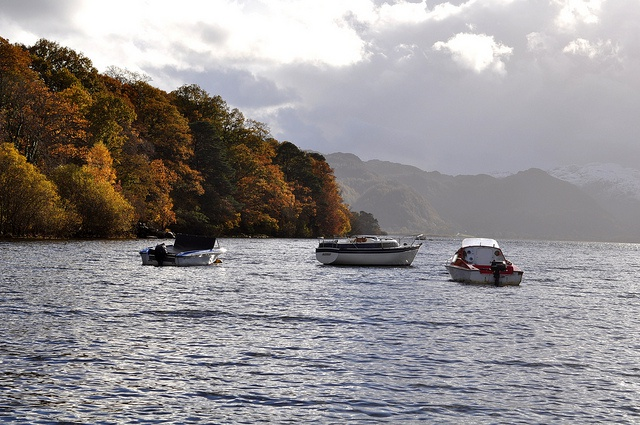Describe the objects in this image and their specific colors. I can see boat in darkgray, gray, black, lightgray, and maroon tones, boat in darkgray, black, gray, and lightgray tones, boat in darkgray, gray, and black tones, boat in darkgray, gray, black, and navy tones, and people in darkgray, black, gray, and lightgray tones in this image. 